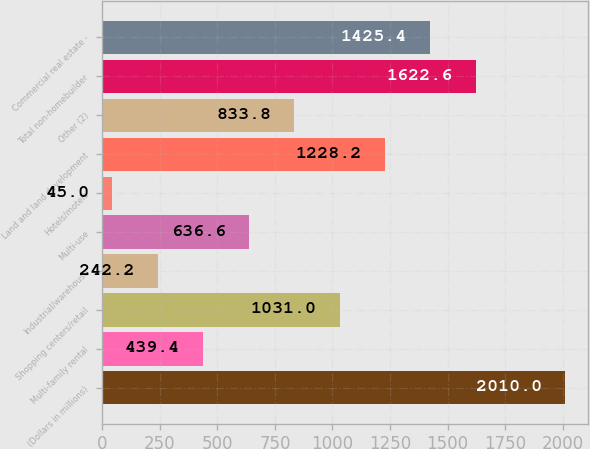Convert chart. <chart><loc_0><loc_0><loc_500><loc_500><bar_chart><fcel>(Dollars in millions)<fcel>Multi-family rental<fcel>Shopping centers/retail<fcel>Industrial/warehouse<fcel>Multi-use<fcel>Hotels/motels<fcel>Land and land development<fcel>Other (2)<fcel>Total non-homebuilder<fcel>Commercial real estate -<nl><fcel>2010<fcel>439.4<fcel>1031<fcel>242.2<fcel>636.6<fcel>45<fcel>1228.2<fcel>833.8<fcel>1622.6<fcel>1425.4<nl></chart> 